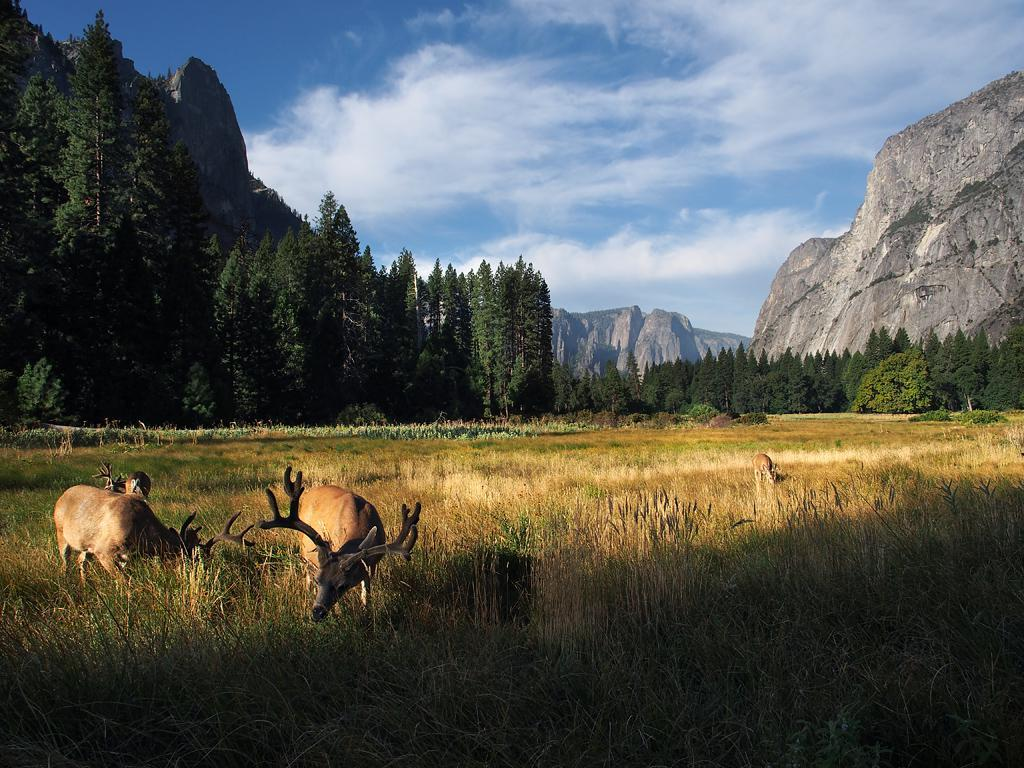What types of living organisms can be seen in the image? Plants and animals are visible in the image. What type of vegetation is present in the image? There are green trees in the image. What geographical feature can be seen in the image? There are mountains in the image. What part of the natural environment is visible in the image? The sky is visible in the background of the image. What type of coil is being used by the representative in the image? There is no representative or coil present in the image. 